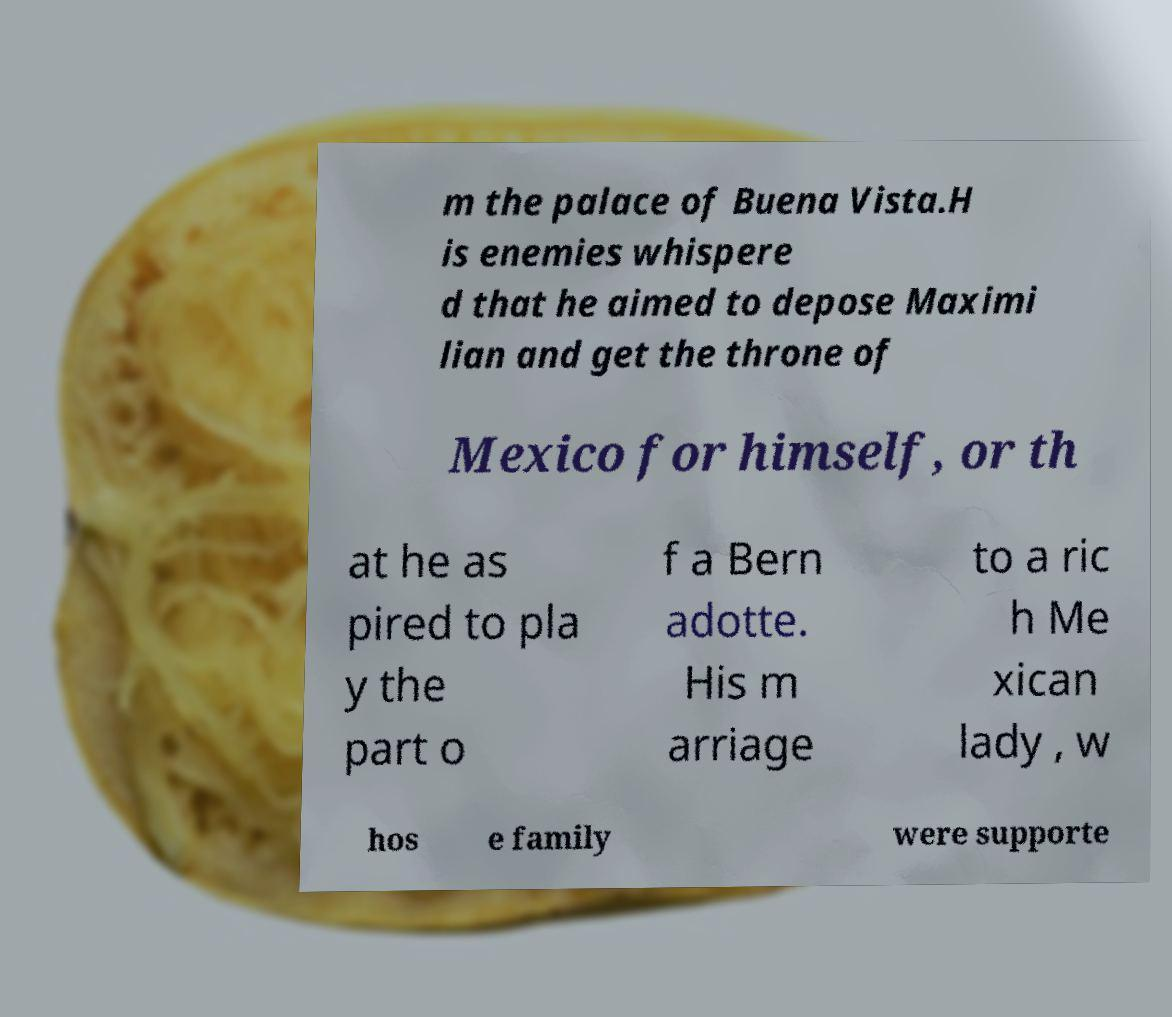Can you accurately transcribe the text from the provided image for me? m the palace of Buena Vista.H is enemies whispere d that he aimed to depose Maximi lian and get the throne of Mexico for himself, or th at he as pired to pla y the part o f a Bern adotte. His m arriage to a ric h Me xican lady , w hos e family were supporte 